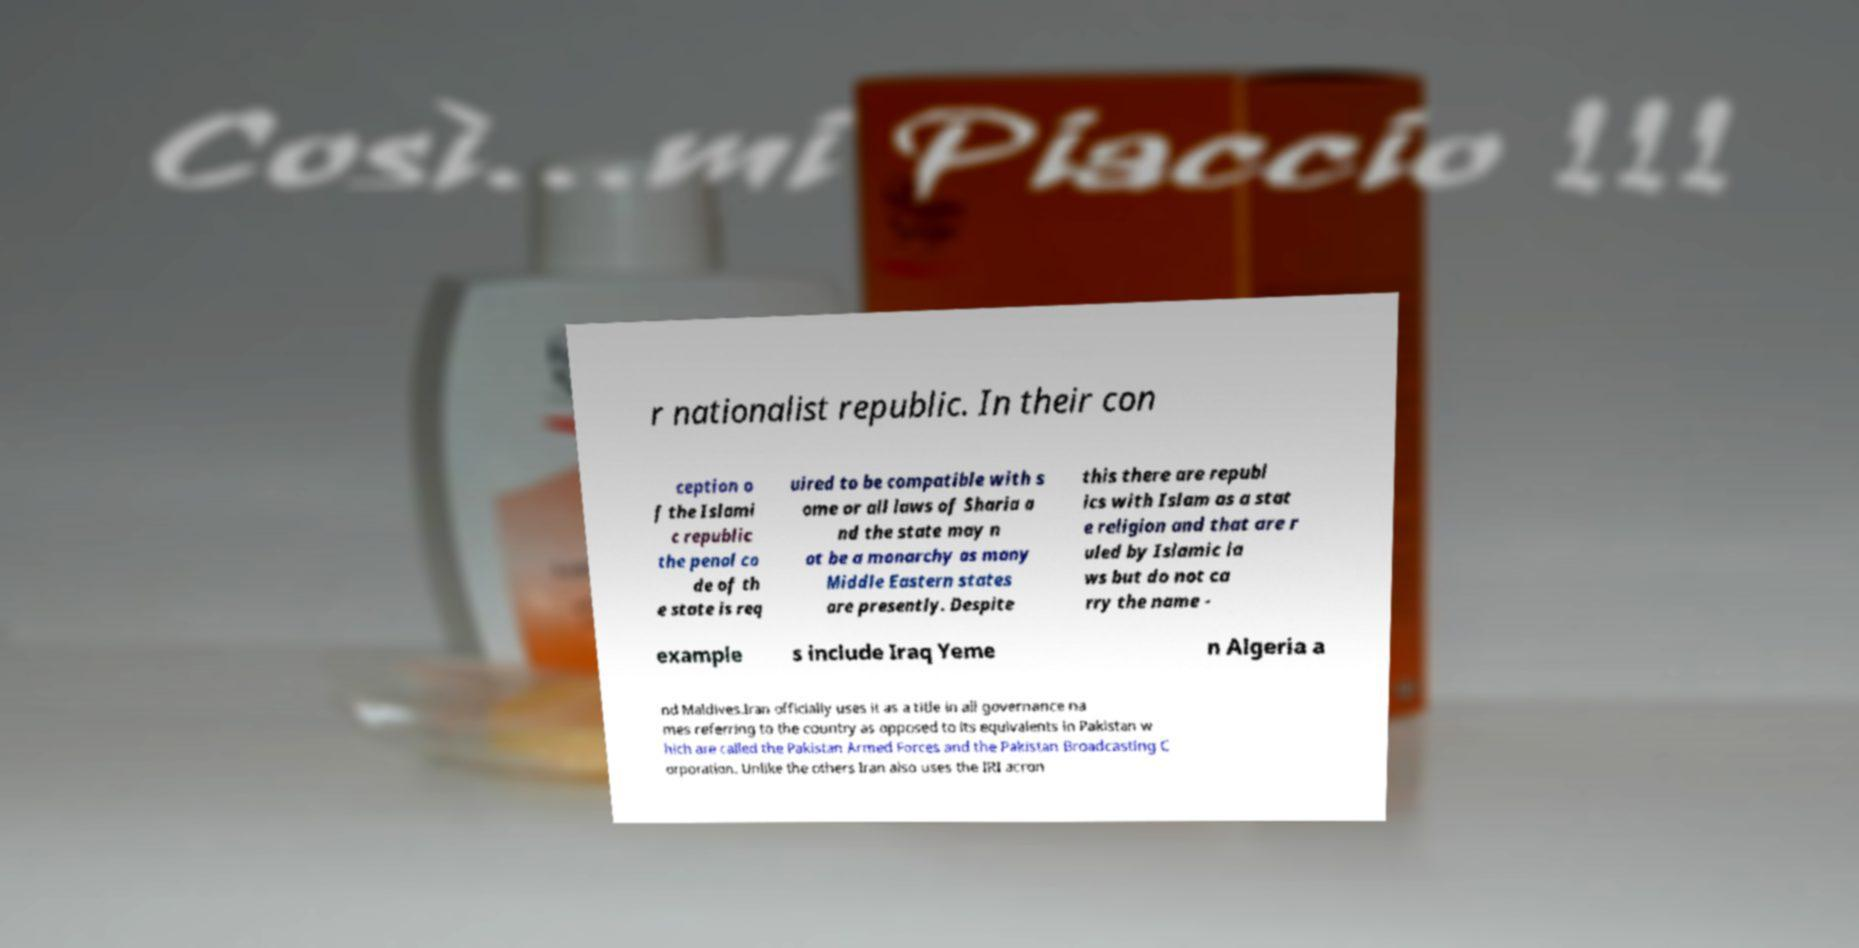Could you extract and type out the text from this image? r nationalist republic. In their con ception o f the Islami c republic the penal co de of th e state is req uired to be compatible with s ome or all laws of Sharia a nd the state may n ot be a monarchy as many Middle Eastern states are presently. Despite this there are republ ics with Islam as a stat e religion and that are r uled by Islamic la ws but do not ca rry the name - example s include Iraq Yeme n Algeria a nd Maldives.Iran officially uses it as a title in all governance na mes referring to the country as opposed to its equivalents in Pakistan w hich are called the Pakistan Armed Forces and the Pakistan Broadcasting C orporation. Unlike the others Iran also uses the IRI acron 